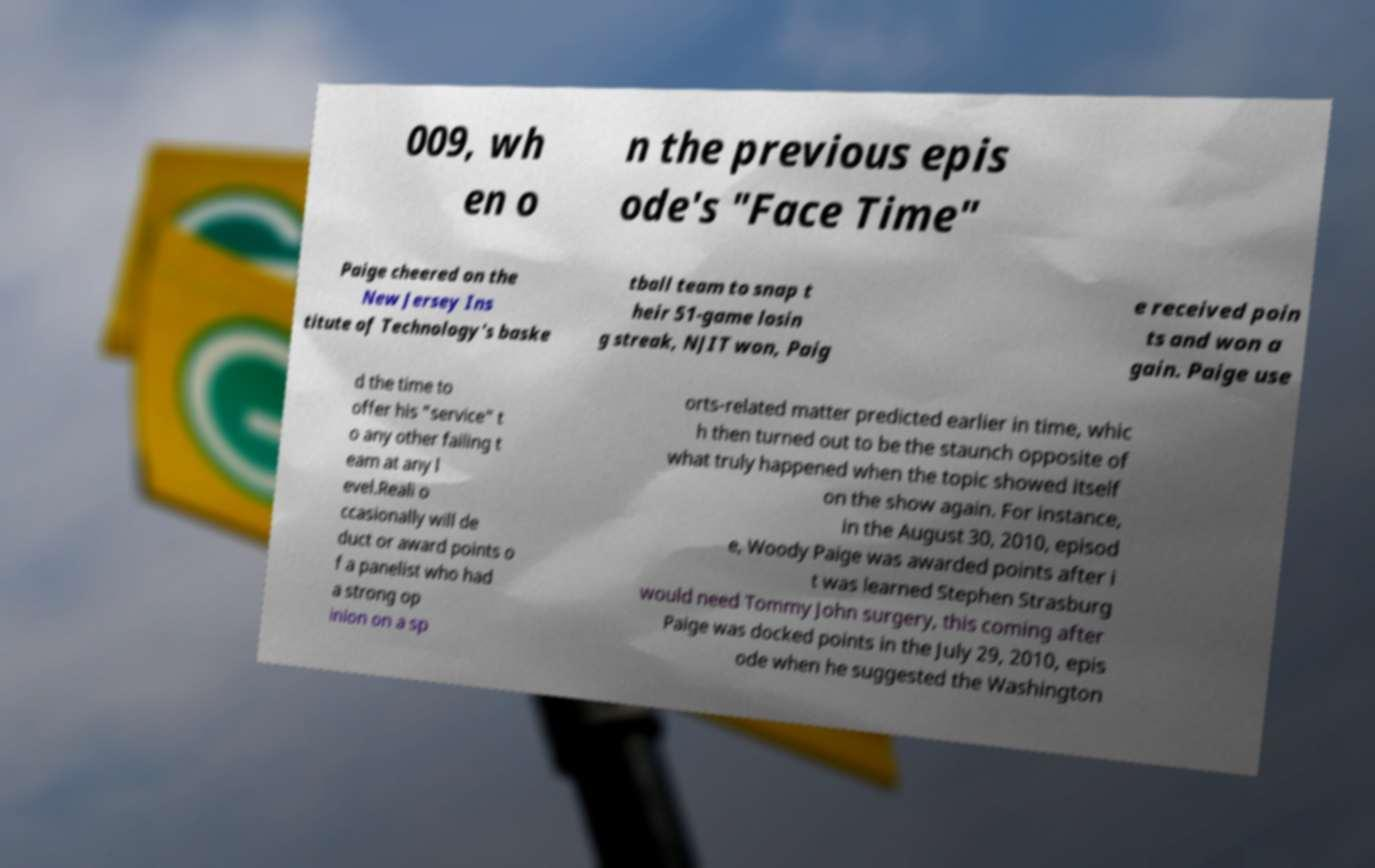What messages or text are displayed in this image? I need them in a readable, typed format. 009, wh en o n the previous epis ode's "Face Time" Paige cheered on the New Jersey Ins titute of Technology's baske tball team to snap t heir 51-game losin g streak, NJIT won, Paig e received poin ts and won a gain. Paige use d the time to offer his "service" t o any other failing t eam at any l evel.Reali o ccasionally will de duct or award points o f a panelist who had a strong op inion on a sp orts-related matter predicted earlier in time, whic h then turned out to be the staunch opposite of what truly happened when the topic showed itself on the show again. For instance, in the August 30, 2010, episod e, Woody Paige was awarded points after i t was learned Stephen Strasburg would need Tommy John surgery, this coming after Paige was docked points in the July 29, 2010, epis ode when he suggested the Washington 